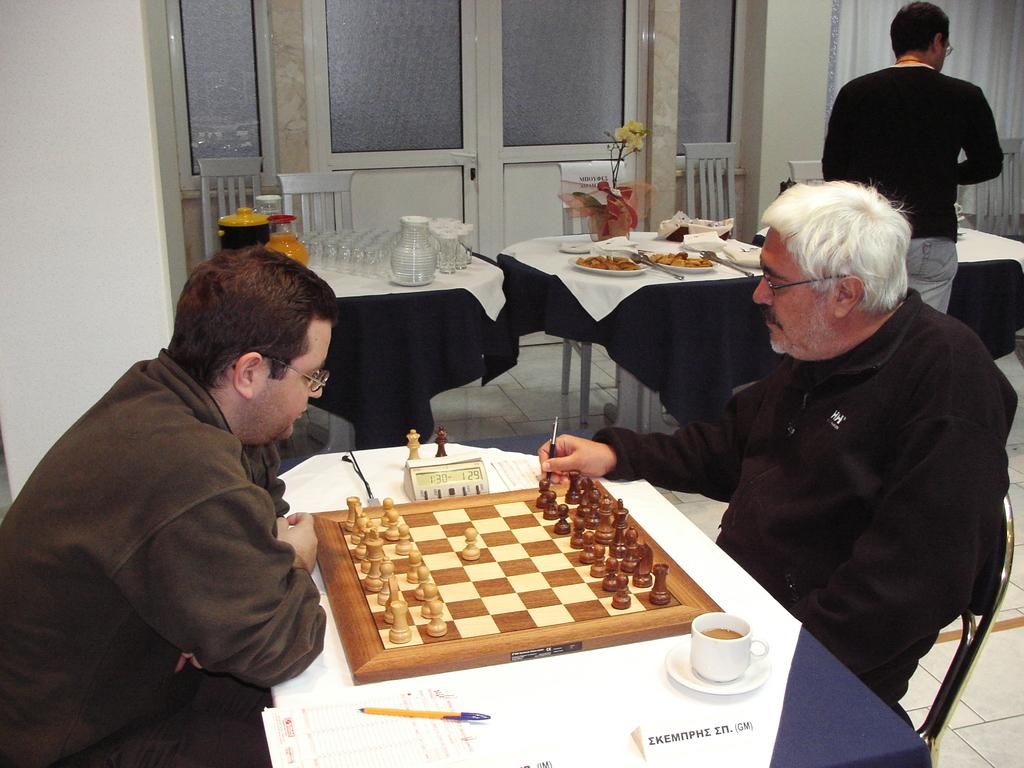How many people are sitting in the image? There are two people sitting on chairs in the image. What is on the table in the image? There is a chess board, a cup, saucers, a pen, and food on the table. What activity might the people be engaged in? The people might be playing chess, as there is a chess board on the table. What can be used for writing or drawing in the image? There is a pen on the table that can be used for writing or drawing. What type of picture is hanging on the wall in the image? There is no picture hanging on the wall in the image. What kind of system is responsible for the chess board's design in the image? The image does not provide information about the design or creation of the chess board, so it is not possible to determine the system responsible for it. 